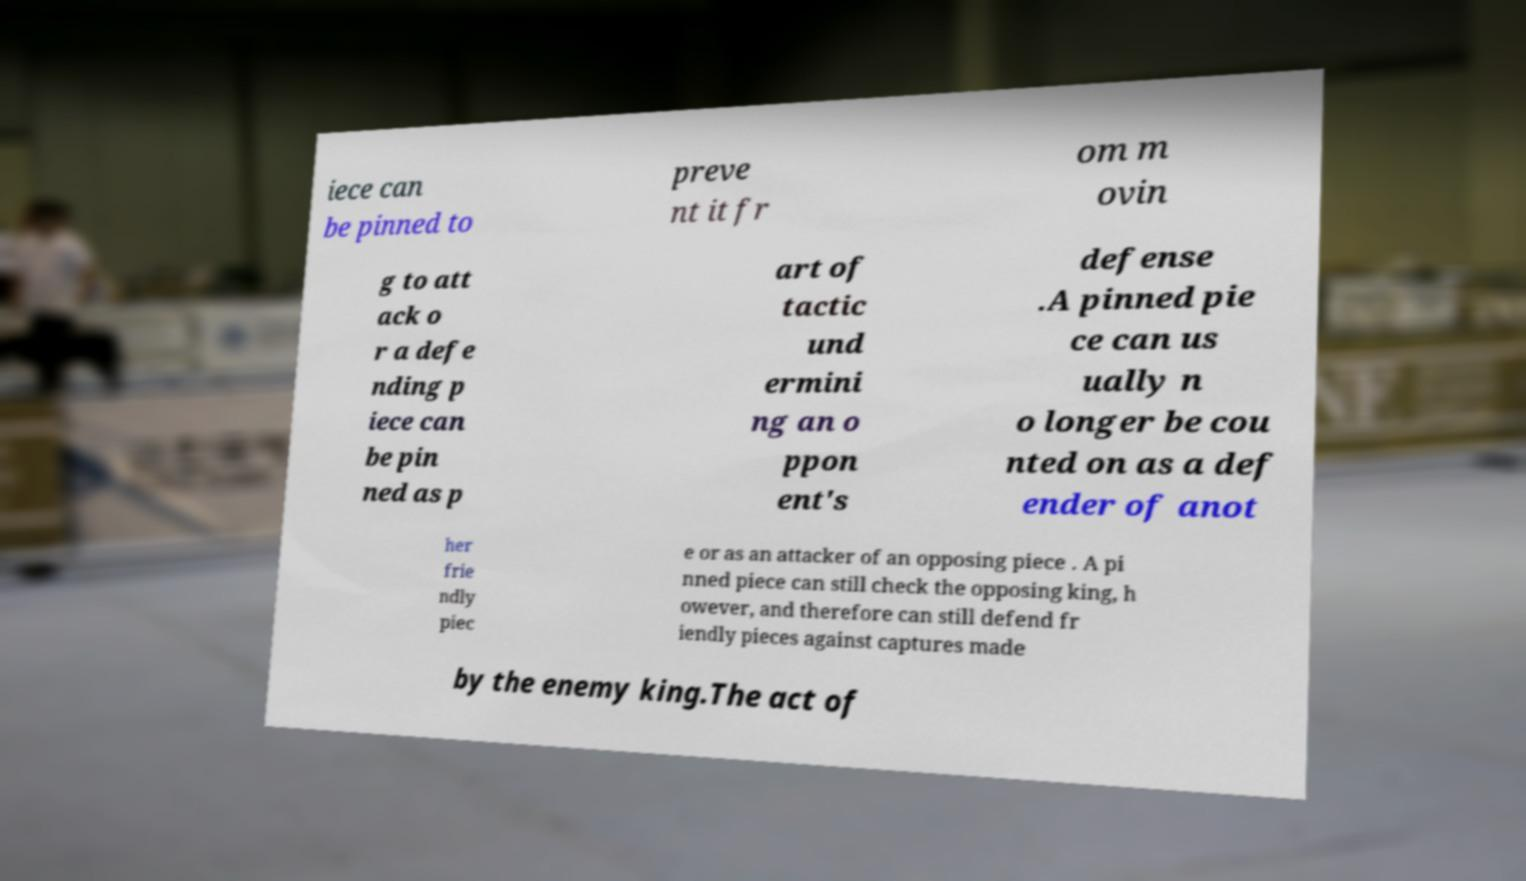I need the written content from this picture converted into text. Can you do that? iece can be pinned to preve nt it fr om m ovin g to att ack o r a defe nding p iece can be pin ned as p art of tactic und ermini ng an o ppon ent's defense .A pinned pie ce can us ually n o longer be cou nted on as a def ender of anot her frie ndly piec e or as an attacker of an opposing piece . A pi nned piece can still check the opposing king, h owever, and therefore can still defend fr iendly pieces against captures made by the enemy king.The act of 